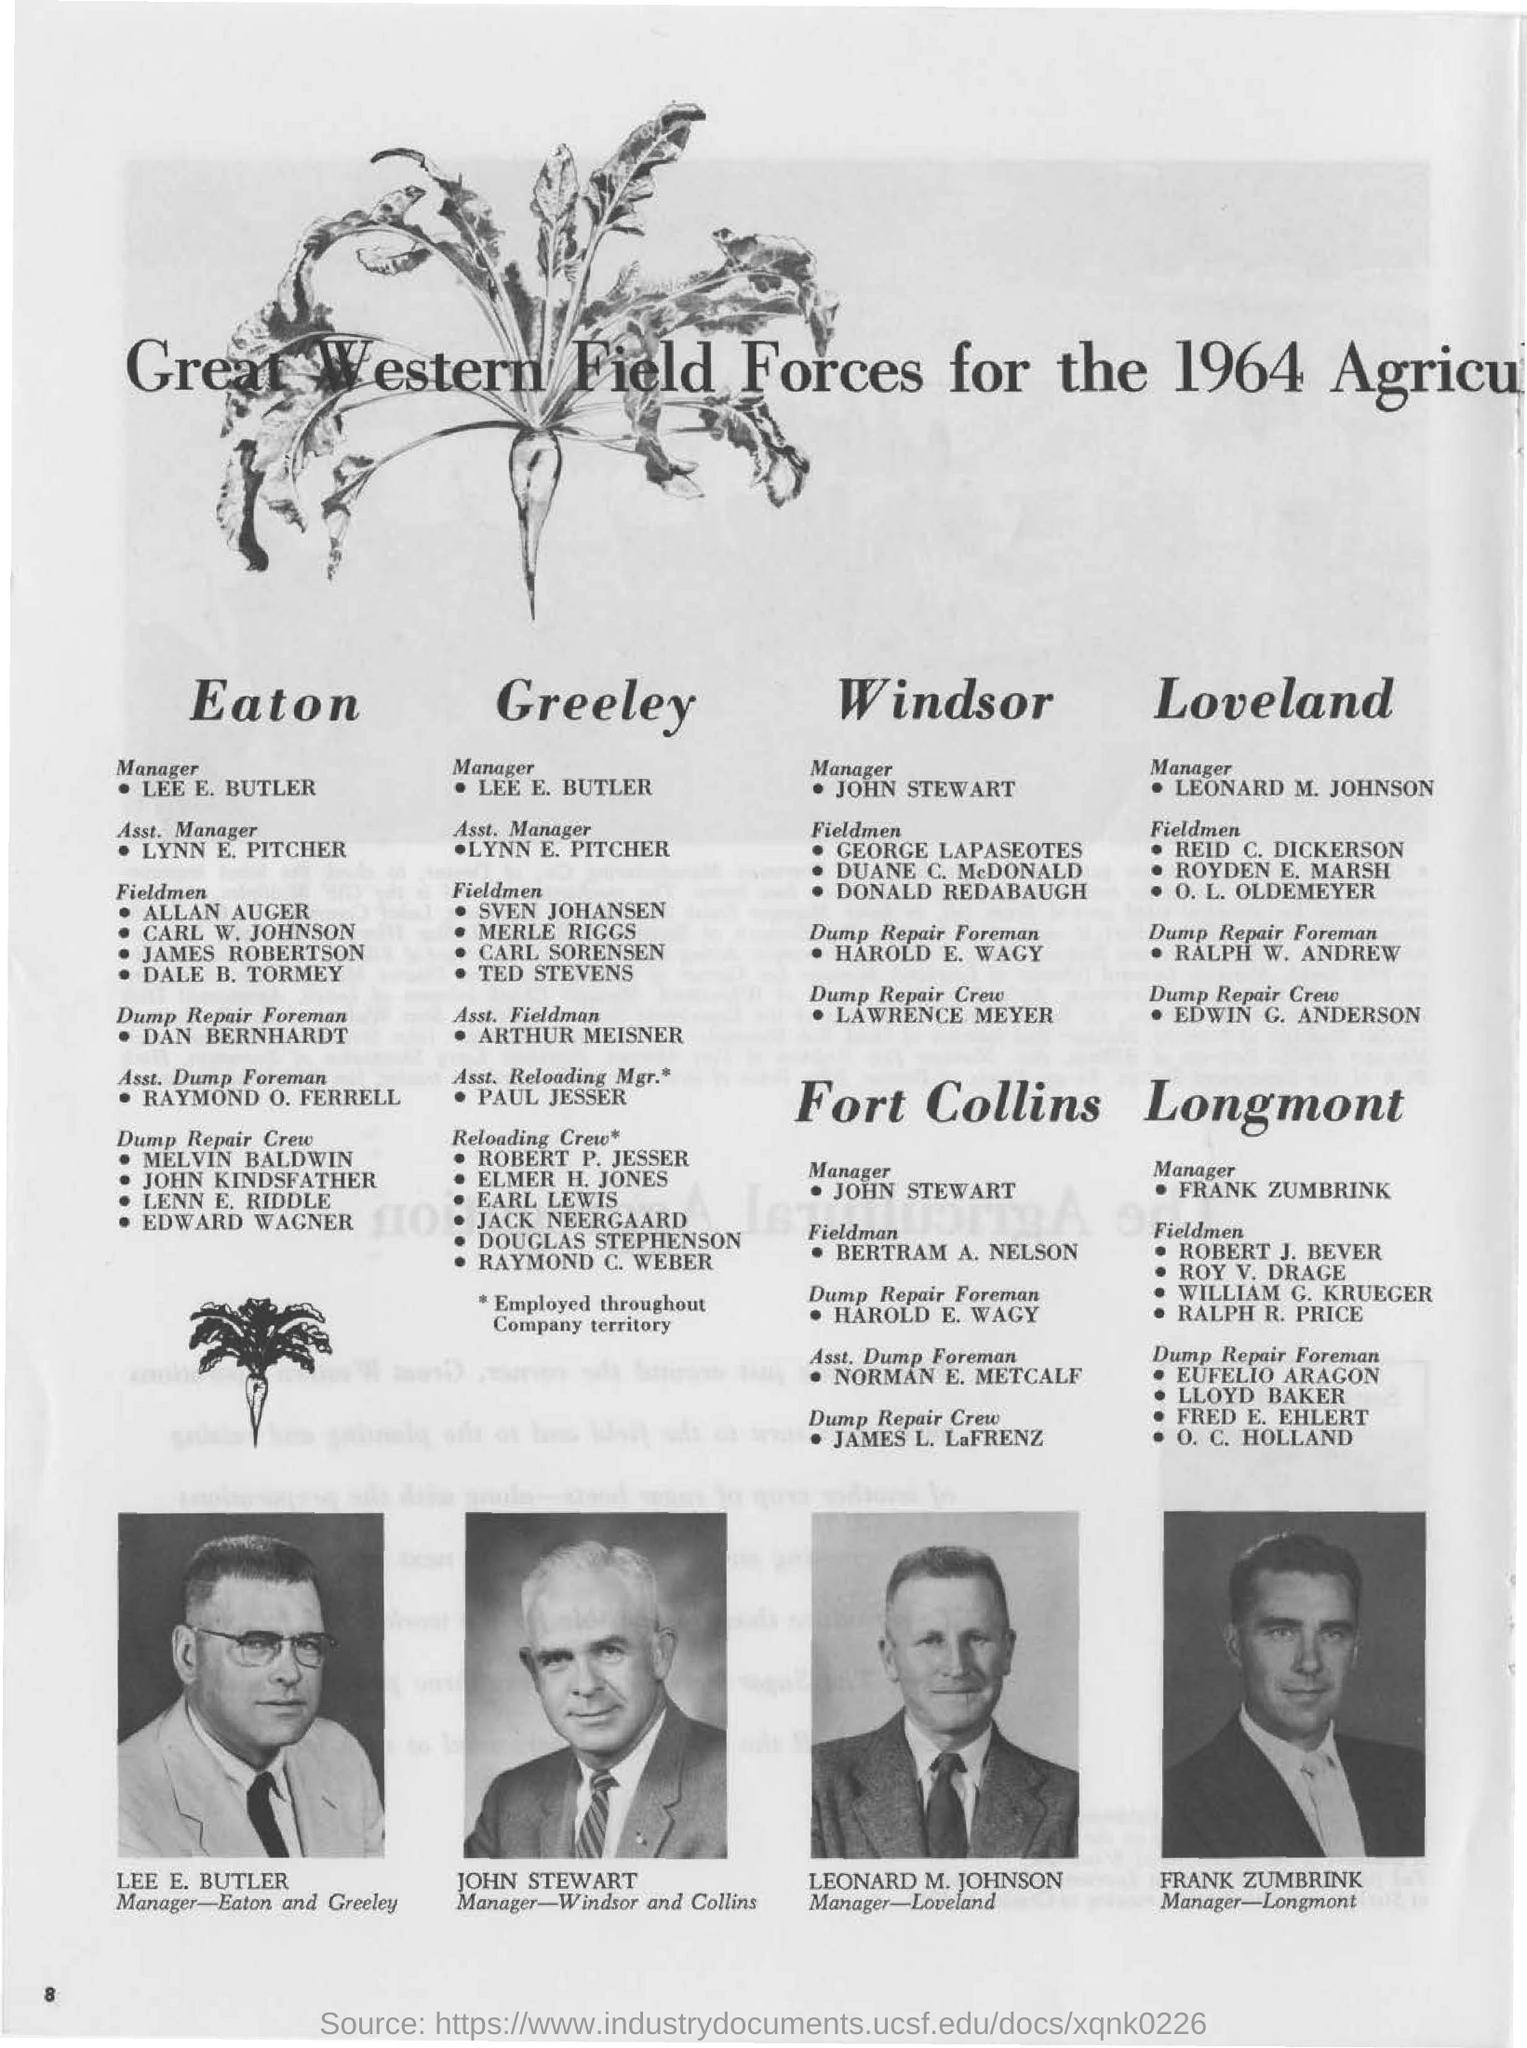Highlight a few significant elements in this photo. The individual identified as Frank Zumbrink is the Manager of Longmont. The individual named LEONARD M. JOHNSON is the Manager-Loveland. The page number mentioned in this document is 8. John Stewart's designation is that of a manager. 